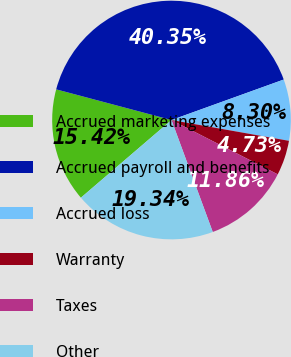<chart> <loc_0><loc_0><loc_500><loc_500><pie_chart><fcel>Accrued marketing expenses<fcel>Accrued payroll and benefits<fcel>Accrued loss<fcel>Warranty<fcel>Taxes<fcel>Other<nl><fcel>15.42%<fcel>40.35%<fcel>8.3%<fcel>4.73%<fcel>11.86%<fcel>19.34%<nl></chart> 